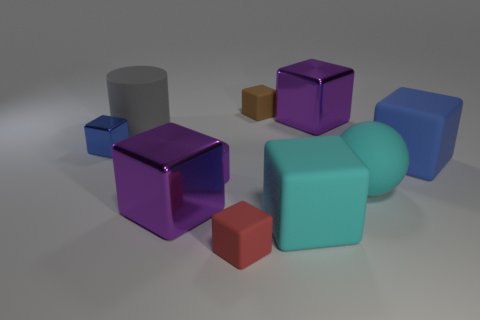Subtract all red rubber blocks. How many blocks are left? 6 Subtract all purple cylinders. How many purple blocks are left? 2 Subtract 4 blocks. How many blocks are left? 3 Subtract all cyan cubes. How many cubes are left? 6 Subtract all yellow blocks. Subtract all green cylinders. How many blocks are left? 7 Subtract all cubes. How many objects are left? 3 Add 8 tiny red rubber things. How many tiny red rubber things exist? 9 Subtract 1 blue blocks. How many objects are left? 9 Subtract all small red rubber balls. Subtract all tiny purple shiny cylinders. How many objects are left? 9 Add 5 tiny blocks. How many tiny blocks are left? 8 